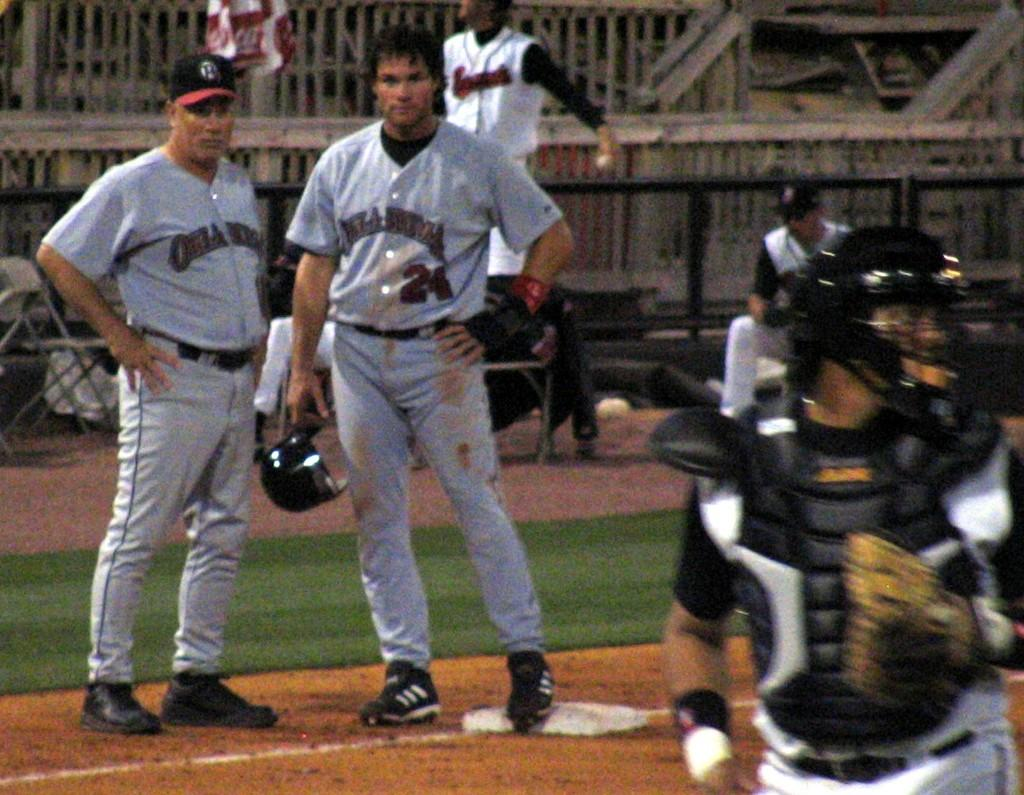How many people are standing in the image? There are two persons standing in the image. What is one of the persons holding? One person is holding a helmet. Can you describe the group of people in the image? There is a group of people in the image, which includes the two standing persons. What type of furniture is present in the image? There is a chair in the image. What type of construction material is visible in the image? There are iron rods in the image. What other items can be seen in the image? There are other items present in the image, but their specific nature is not mentioned in the provided facts. What color is the crayon being used by the person holding the helmet in the image? There is no crayon present in the image. What type of sound can be heard coming from the helmet in the image? There is no sound coming from the helmet in the image. 